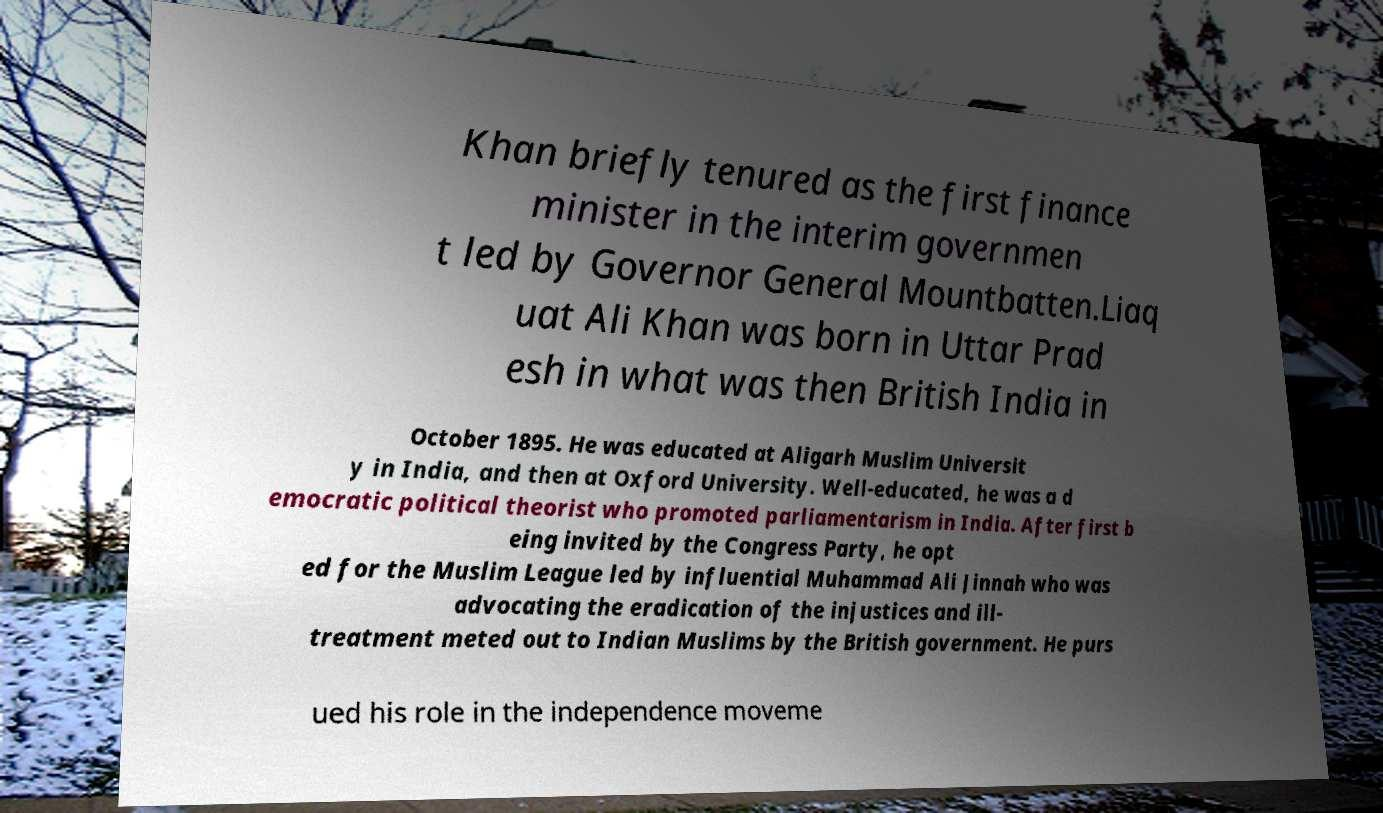I need the written content from this picture converted into text. Can you do that? Khan briefly tenured as the first finance minister in the interim governmen t led by Governor General Mountbatten.Liaq uat Ali Khan was born in Uttar Prad esh in what was then British India in October 1895. He was educated at Aligarh Muslim Universit y in India, and then at Oxford University. Well-educated, he was a d emocratic political theorist who promoted parliamentarism in India. After first b eing invited by the Congress Party, he opt ed for the Muslim League led by influential Muhammad Ali Jinnah who was advocating the eradication of the injustices and ill- treatment meted out to Indian Muslims by the British government. He purs ued his role in the independence moveme 